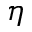<formula> <loc_0><loc_0><loc_500><loc_500>\eta</formula> 